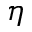<formula> <loc_0><loc_0><loc_500><loc_500>\eta</formula> 